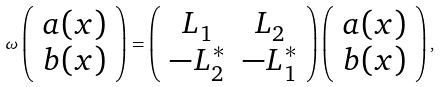<formula> <loc_0><loc_0><loc_500><loc_500>\omega \left ( \begin{array} { c } a ( x ) \\ b ( x ) \end{array} \right ) = \left ( \begin{array} { c c } L _ { 1 } & L _ { 2 } \\ - L _ { 2 } ^ { * } & - L _ { 1 } ^ { * } \end{array} \right ) \left ( \begin{array} { c } a ( x ) \\ b ( x ) \end{array} \right ) ,</formula> 